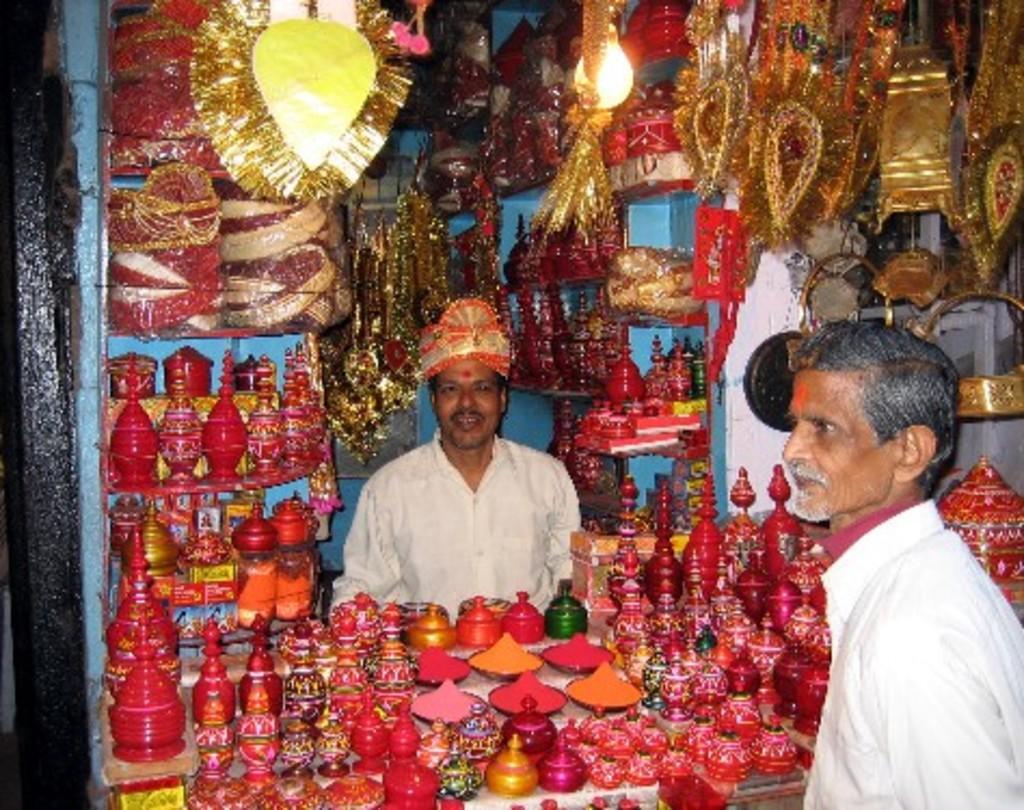How would you summarize this image in a sentence or two? In the center of the image we can see a man sitting. We can also see a group of decors placed in the shelves and on the table. We can also see some ribbons, a bulb and some caps. On the right side we can see a man standing. 